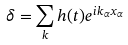<formula> <loc_0><loc_0><loc_500><loc_500>\delta = \sum _ { k } h ( t ) e ^ { i k _ { \alpha } x _ { \alpha } }</formula> 